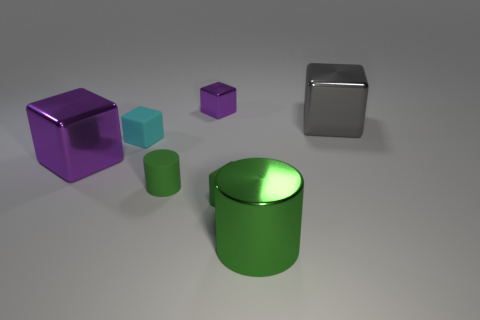Subtract all small cyan rubber blocks. How many blocks are left? 4 Subtract all blocks. How many objects are left? 2 Add 2 cyan things. How many objects exist? 9 Subtract 1 cubes. How many cubes are left? 4 Subtract all green blocks. How many blocks are left? 4 Subtract 0 red balls. How many objects are left? 7 Subtract all blue cylinders. Subtract all red balls. How many cylinders are left? 2 Subtract all red cubes. How many yellow cylinders are left? 0 Subtract all large purple metal cubes. Subtract all green things. How many objects are left? 3 Add 1 metallic blocks. How many metallic blocks are left? 4 